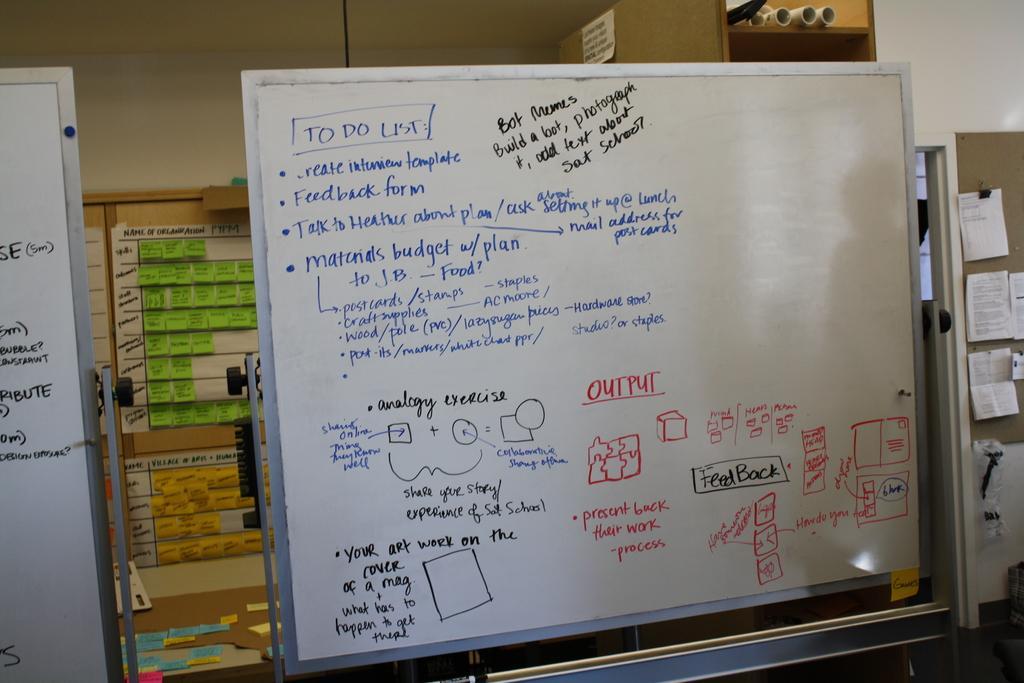In one or two sentences, can you explain what this image depicts? In the image in the center, we can see the boards and notes. And we can see something written on the board. In the background there is a wall, notes, charts and a few other objects. 